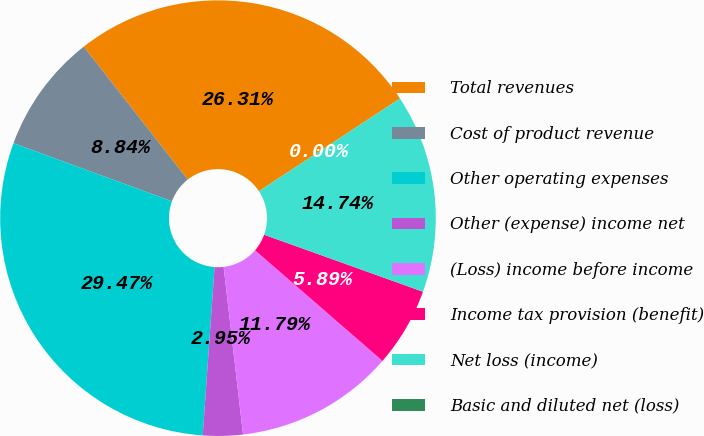<chart> <loc_0><loc_0><loc_500><loc_500><pie_chart><fcel>Total revenues<fcel>Cost of product revenue<fcel>Other operating expenses<fcel>Other (expense) income net<fcel>(Loss) income before income<fcel>Income tax provision (benefit)<fcel>Net loss (income)<fcel>Basic and diluted net (loss)<nl><fcel>26.31%<fcel>8.84%<fcel>29.47%<fcel>2.95%<fcel>11.79%<fcel>5.89%<fcel>14.74%<fcel>0.0%<nl></chart> 